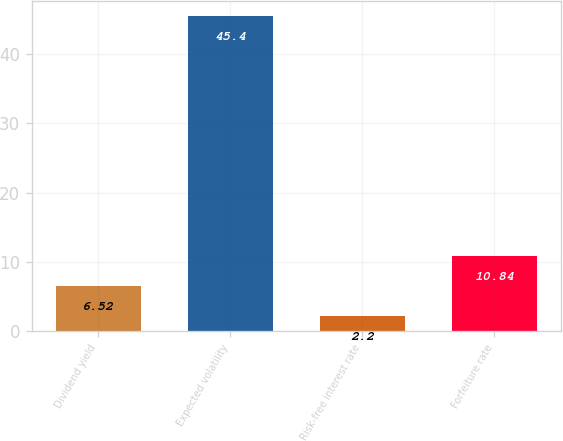<chart> <loc_0><loc_0><loc_500><loc_500><bar_chart><fcel>Dividend yield<fcel>Expected volatility<fcel>Risk-free interest rate<fcel>Forfeiture rate<nl><fcel>6.52<fcel>45.4<fcel>2.2<fcel>10.84<nl></chart> 